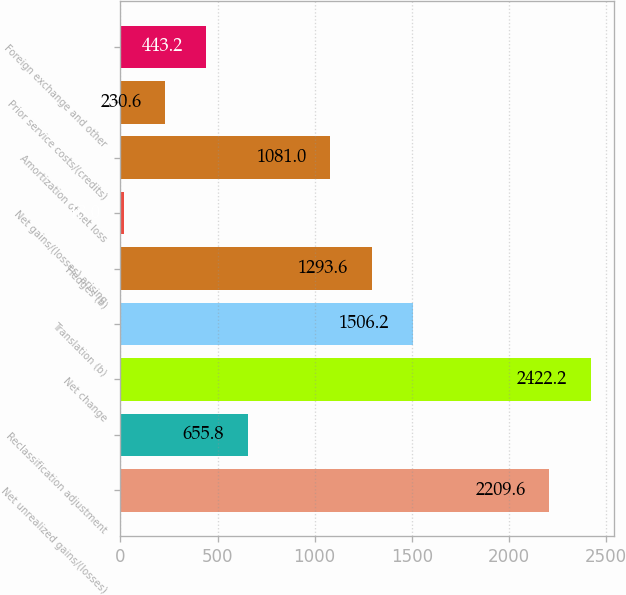Convert chart to OTSL. <chart><loc_0><loc_0><loc_500><loc_500><bar_chart><fcel>Net unrealized gains/(losses)<fcel>Reclassification adjustment<fcel>Net change<fcel>Translation (b)<fcel>Hedges (b)<fcel>Net gains/(losses) arising<fcel>Amortization of net loss<fcel>Prior service costs/(credits)<fcel>Foreign exchange and other<nl><fcel>2209.6<fcel>655.8<fcel>2422.2<fcel>1506.2<fcel>1293.6<fcel>18<fcel>1081<fcel>230.6<fcel>443.2<nl></chart> 